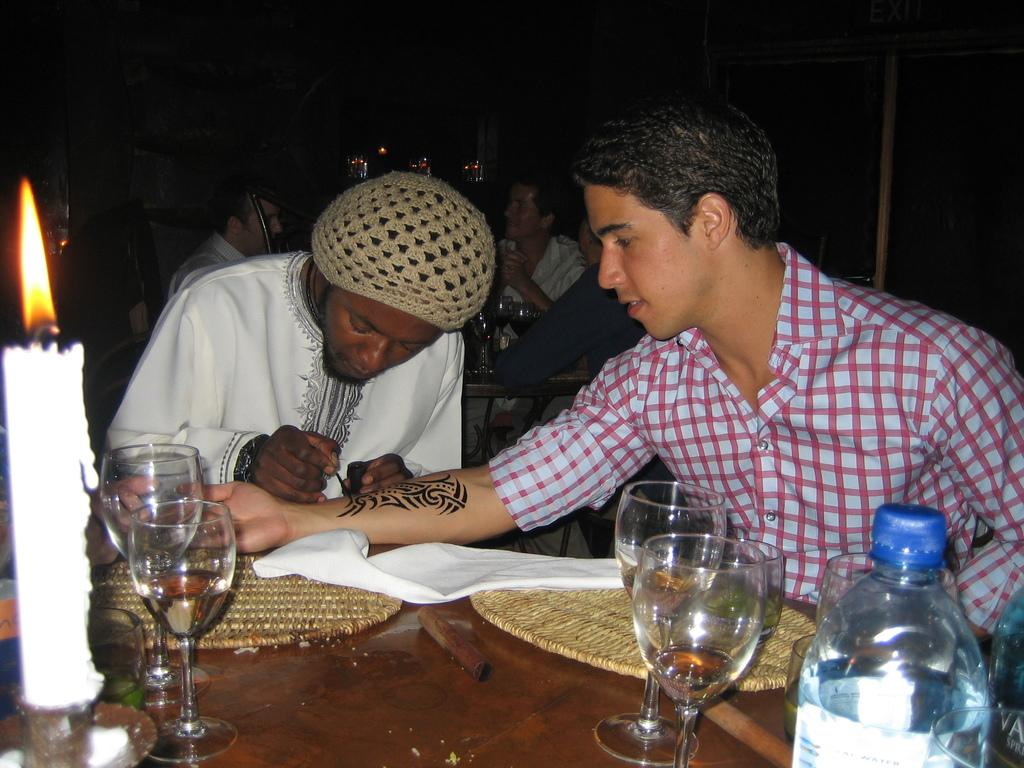What is the person in the white dress doing in the image? The person in the white dress is drawing a tattoo. Who is present with the person drawing the tattoo? There is a person sitting beside the person drawing the tattoo. Can you describe the scene in the background of the image? There are people in the background of the image. What type of advertisement can be seen on the wall behind the person drawing the tattoo? There is no advertisement visible on the wall behind the person drawing the tattoo in the image. 